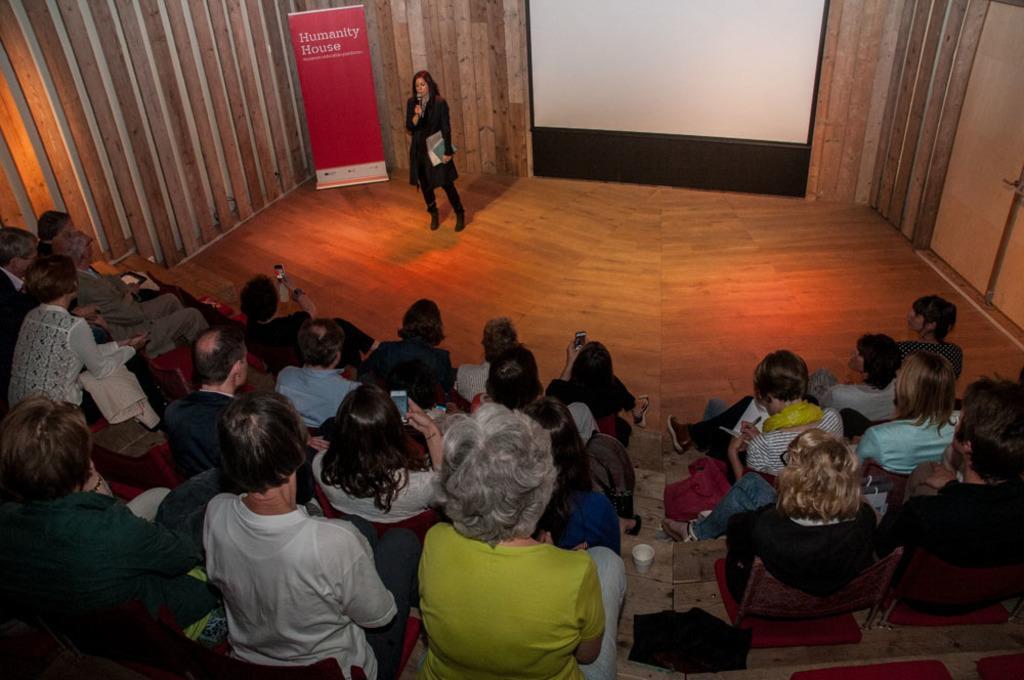Describe this image in one or two sentences. In this picture we can see some people sitting on chairs here, we can see a woman standing and holding a microphone, there is a hoarding here, we can see a screen here, this person is writing something, we can see a cup here. 